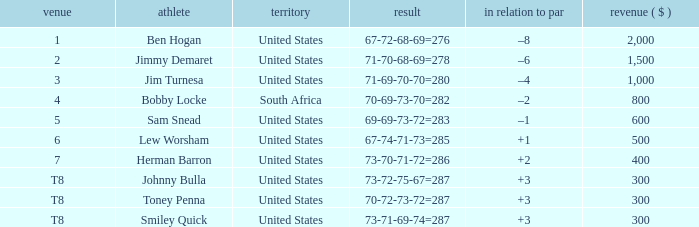What is the Place of the Player with a To par of –1? 5.0. 